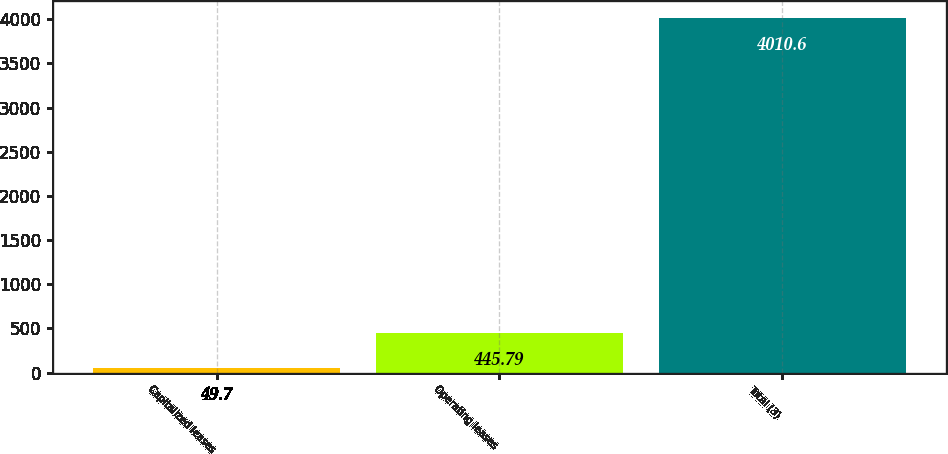Convert chart. <chart><loc_0><loc_0><loc_500><loc_500><bar_chart><fcel>Capitalized leases<fcel>Operating leases<fcel>Total (3)<nl><fcel>49.7<fcel>445.79<fcel>4010.6<nl></chart> 